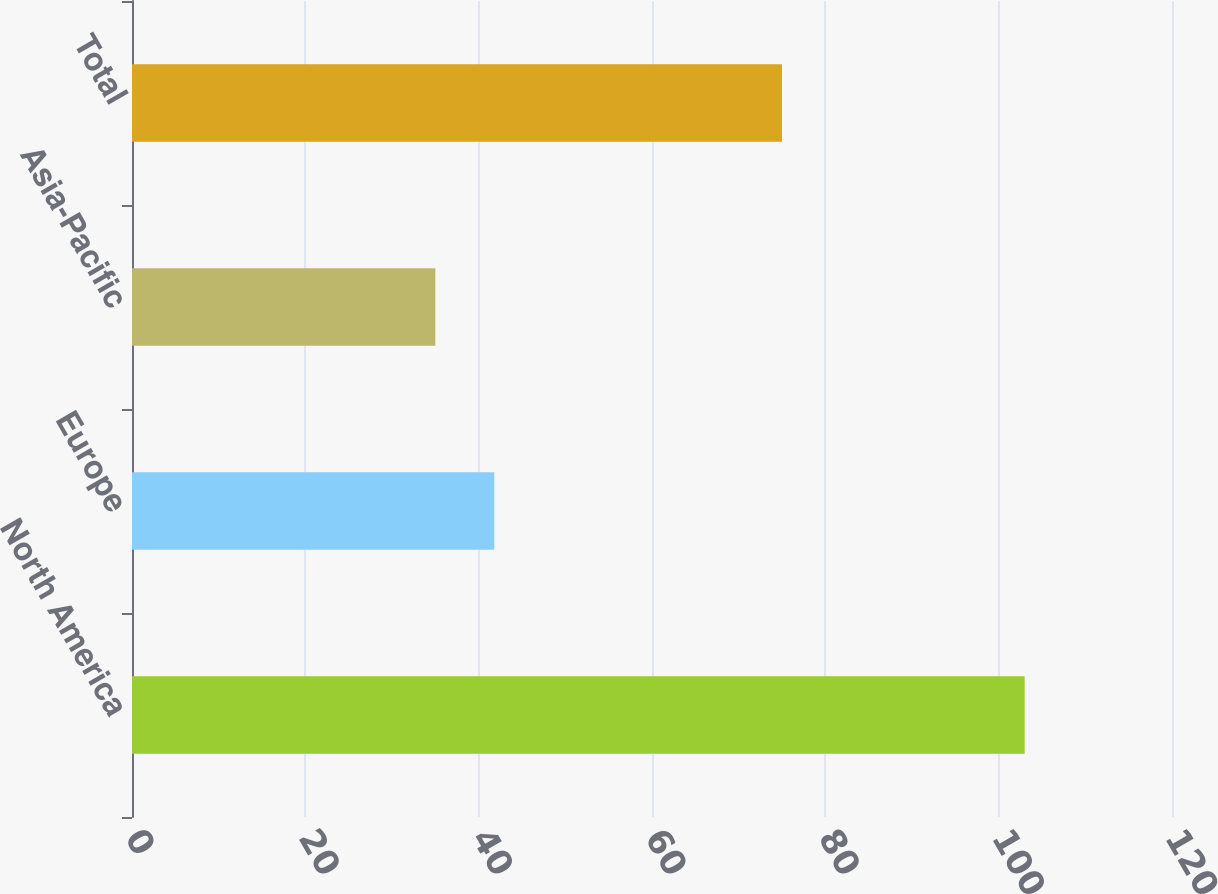Convert chart. <chart><loc_0><loc_0><loc_500><loc_500><bar_chart><fcel>North America<fcel>Europe<fcel>Asia-Pacific<fcel>Total<nl><fcel>103<fcel>41.8<fcel>35<fcel>75<nl></chart> 